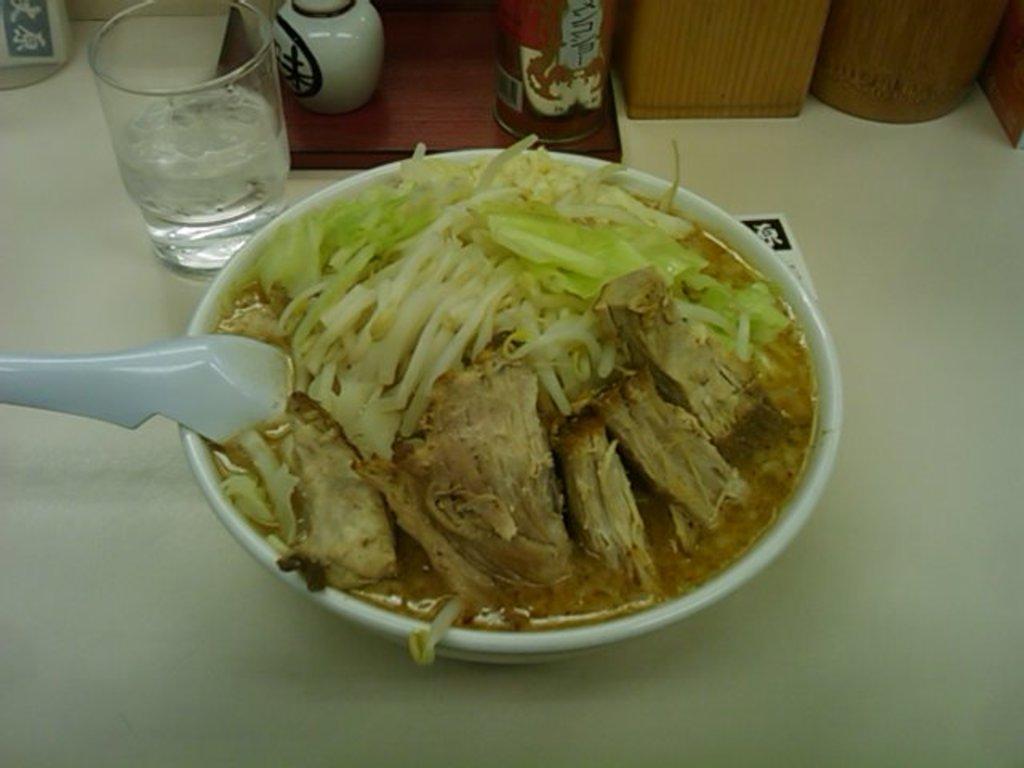How would you summarize this image in a sentence or two? In this picture we can see bowl with food and spoon, glass and objects on the platform. 